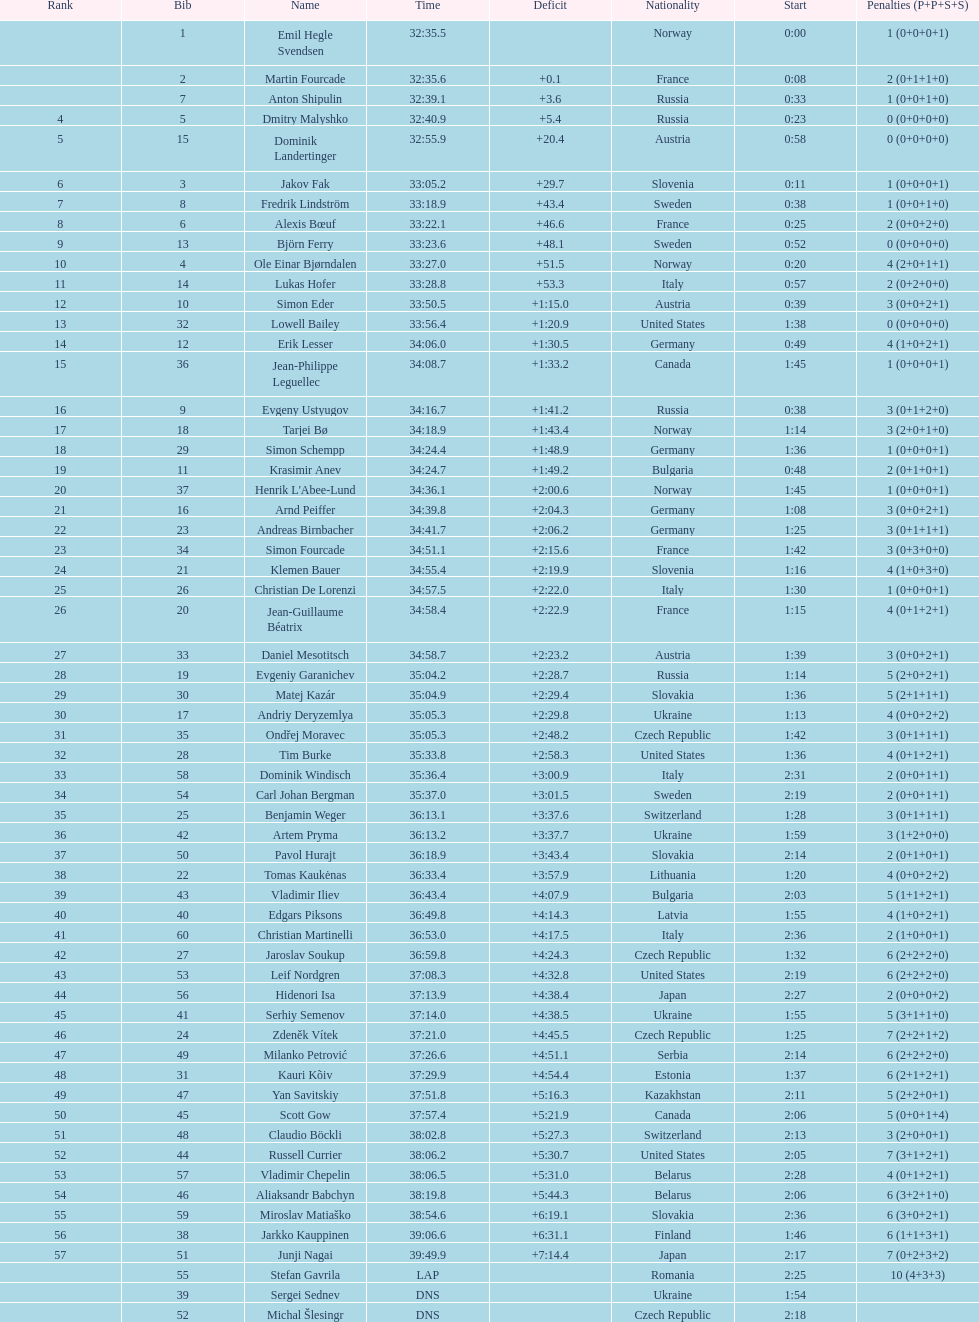Between bjorn ferry, simon elder, and erik lesser - who experienced the highest number of penalties? Erik Lesser. 